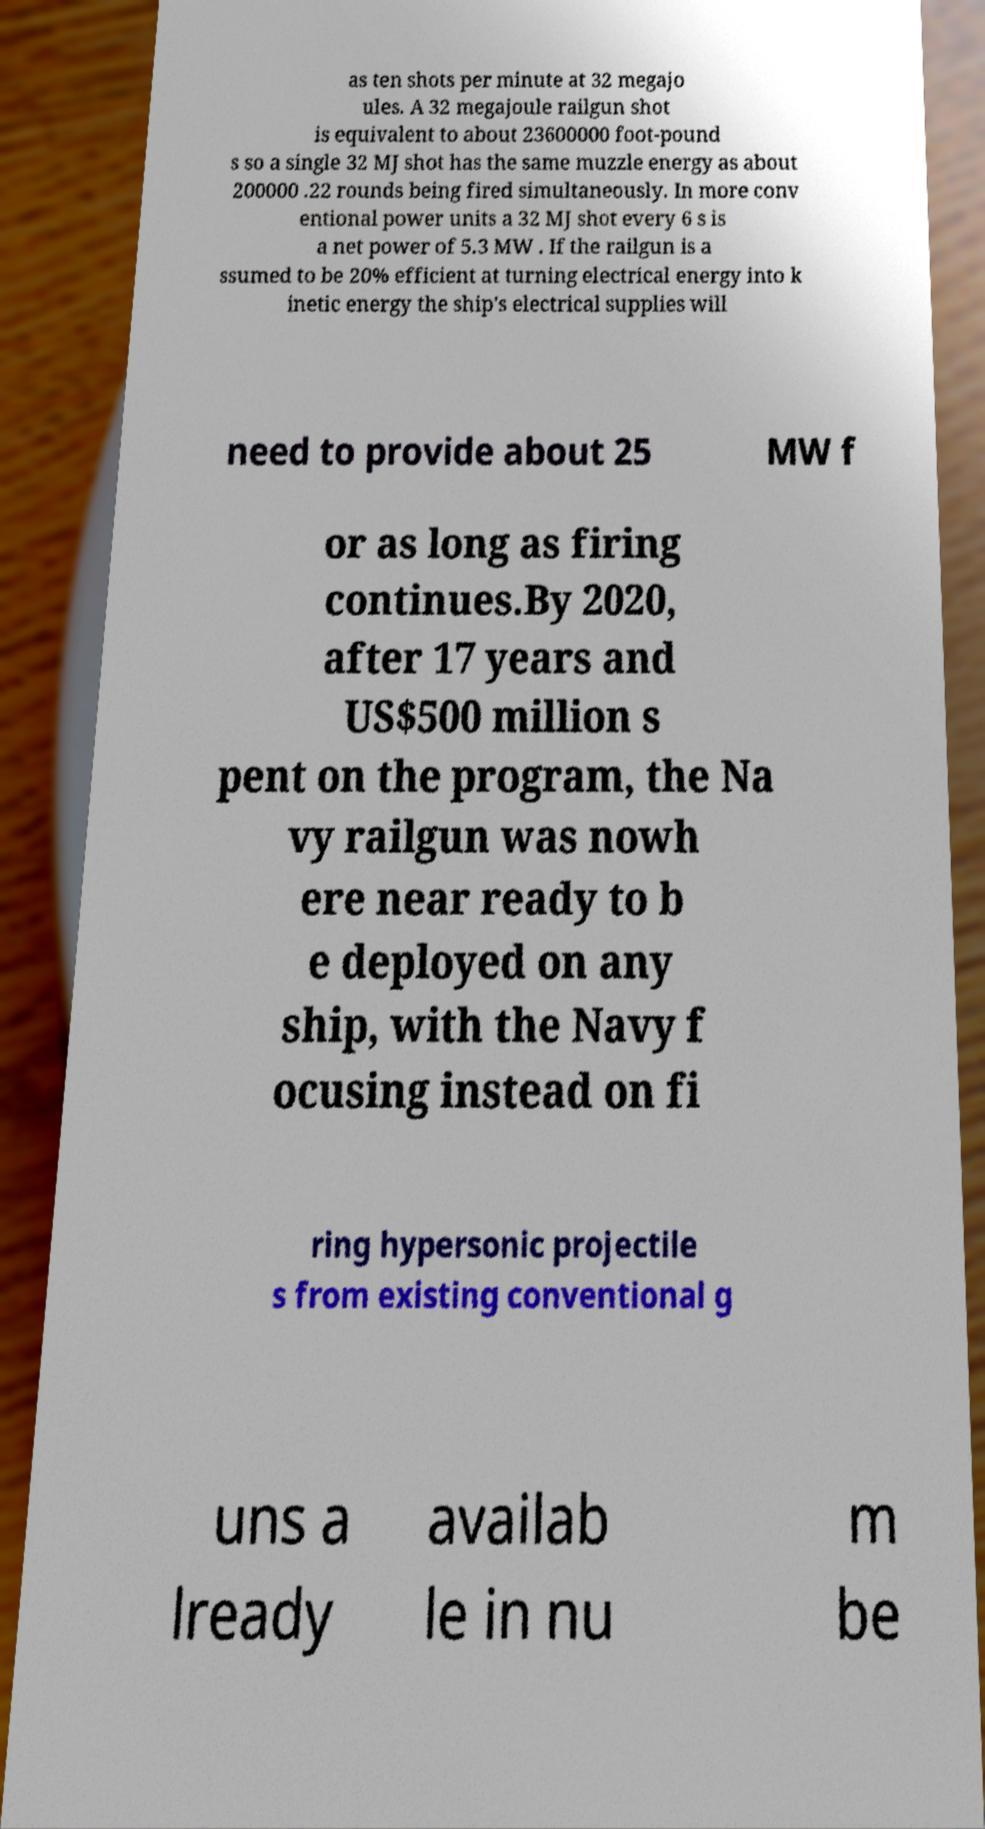There's text embedded in this image that I need extracted. Can you transcribe it verbatim? as ten shots per minute at 32 megajo ules. A 32 megajoule railgun shot is equivalent to about 23600000 foot-pound s so a single 32 MJ shot has the same muzzle energy as about 200000 .22 rounds being fired simultaneously. In more conv entional power units a 32 MJ shot every 6 s is a net power of 5.3 MW . If the railgun is a ssumed to be 20% efficient at turning electrical energy into k inetic energy the ship's electrical supplies will need to provide about 25 MW f or as long as firing continues.By 2020, after 17 years and US$500 million s pent on the program, the Na vy railgun was nowh ere near ready to b e deployed on any ship, with the Navy f ocusing instead on fi ring hypersonic projectile s from existing conventional g uns a lready availab le in nu m be 